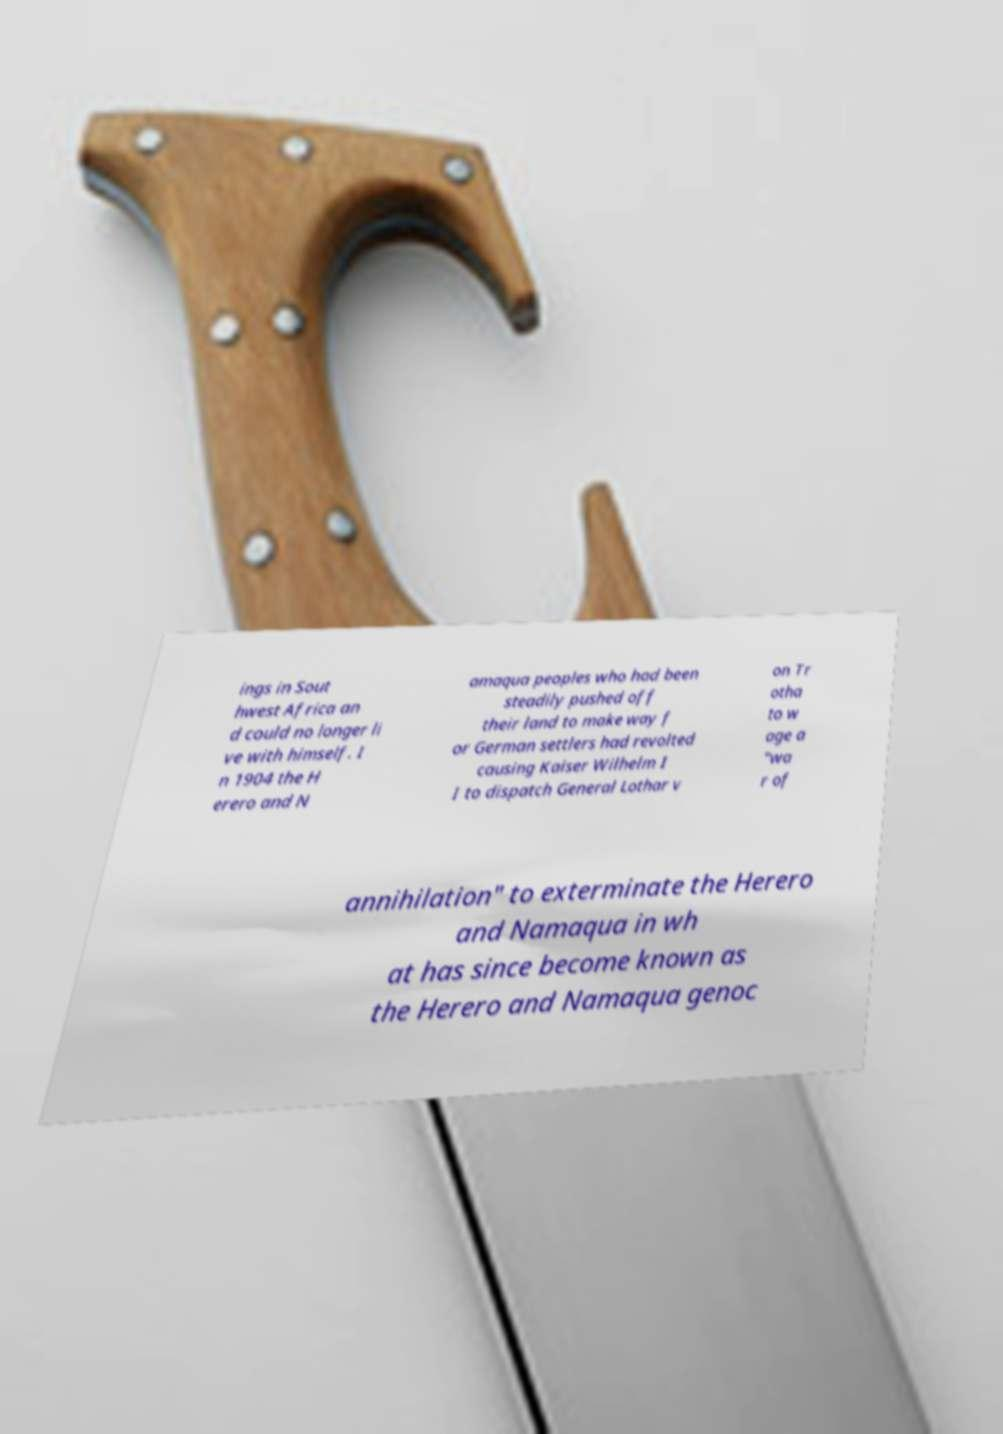Could you extract and type out the text from this image? ings in Sout hwest Africa an d could no longer li ve with himself. I n 1904 the H erero and N amaqua peoples who had been steadily pushed off their land to make way f or German settlers had revolted causing Kaiser Wilhelm I I to dispatch General Lothar v on Tr otha to w age a "wa r of annihilation" to exterminate the Herero and Namaqua in wh at has since become known as the Herero and Namaqua genoc 